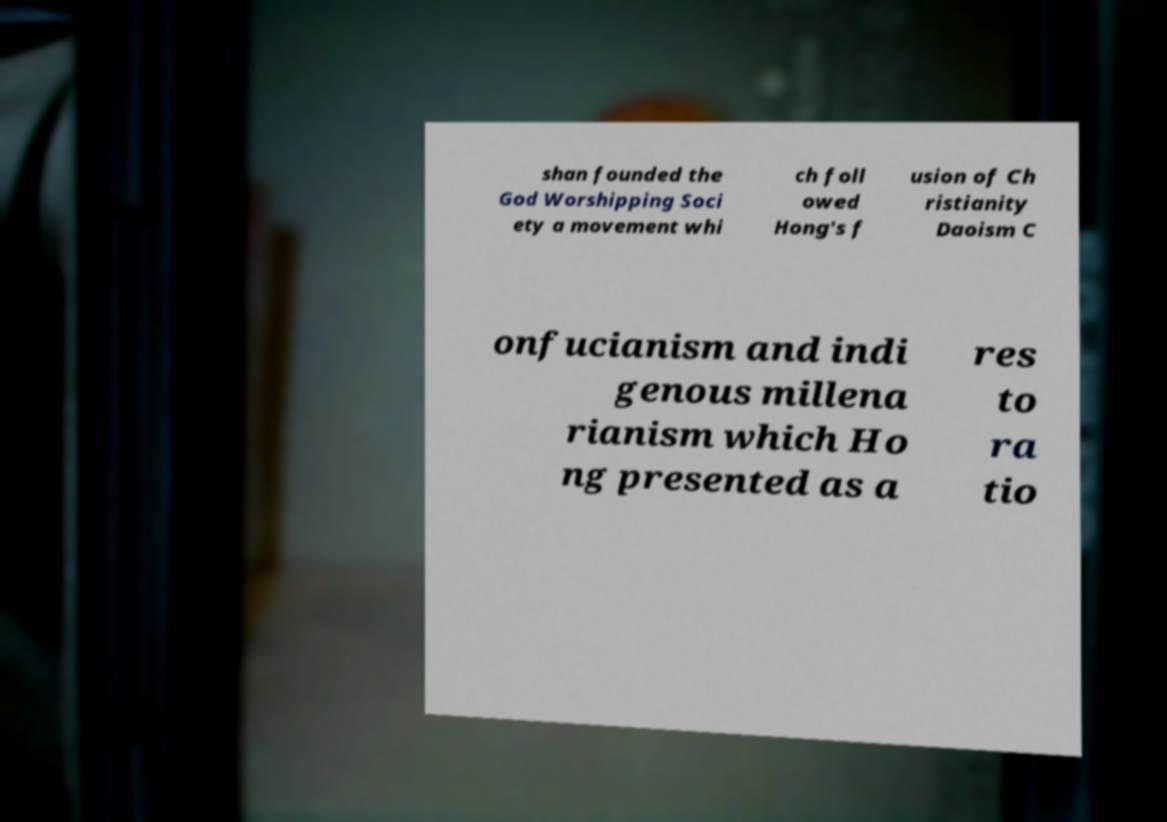I need the written content from this picture converted into text. Can you do that? shan founded the God Worshipping Soci ety a movement whi ch foll owed Hong's f usion of Ch ristianity Daoism C onfucianism and indi genous millena rianism which Ho ng presented as a res to ra tio 